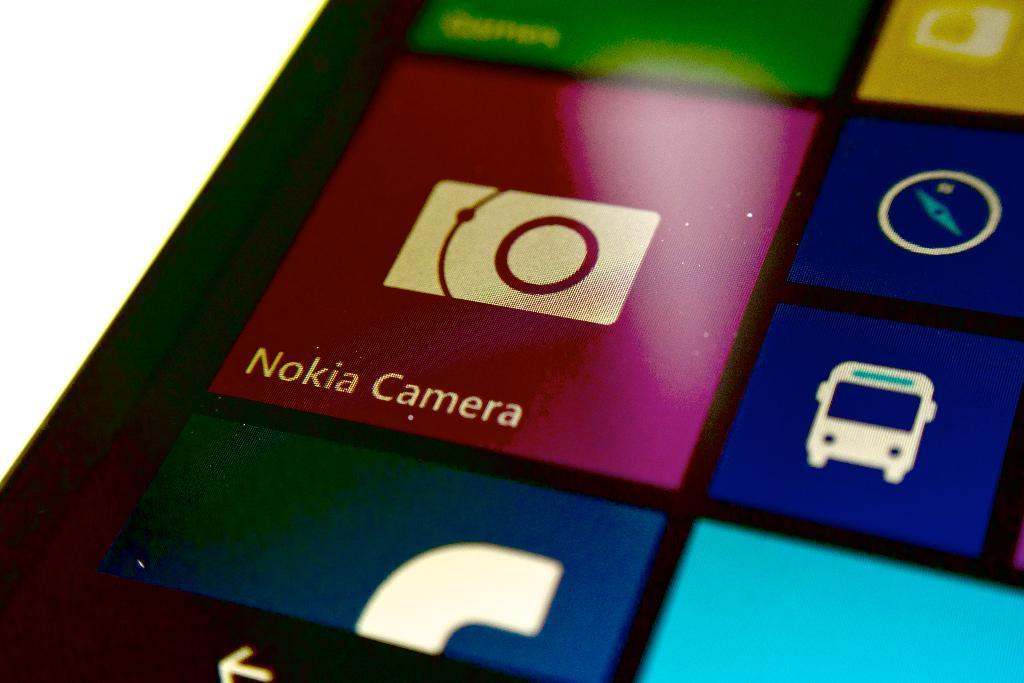<image>
Relay a brief, clear account of the picture shown. A phone display shows several apps that can be selected including the Nokia Camera app. 